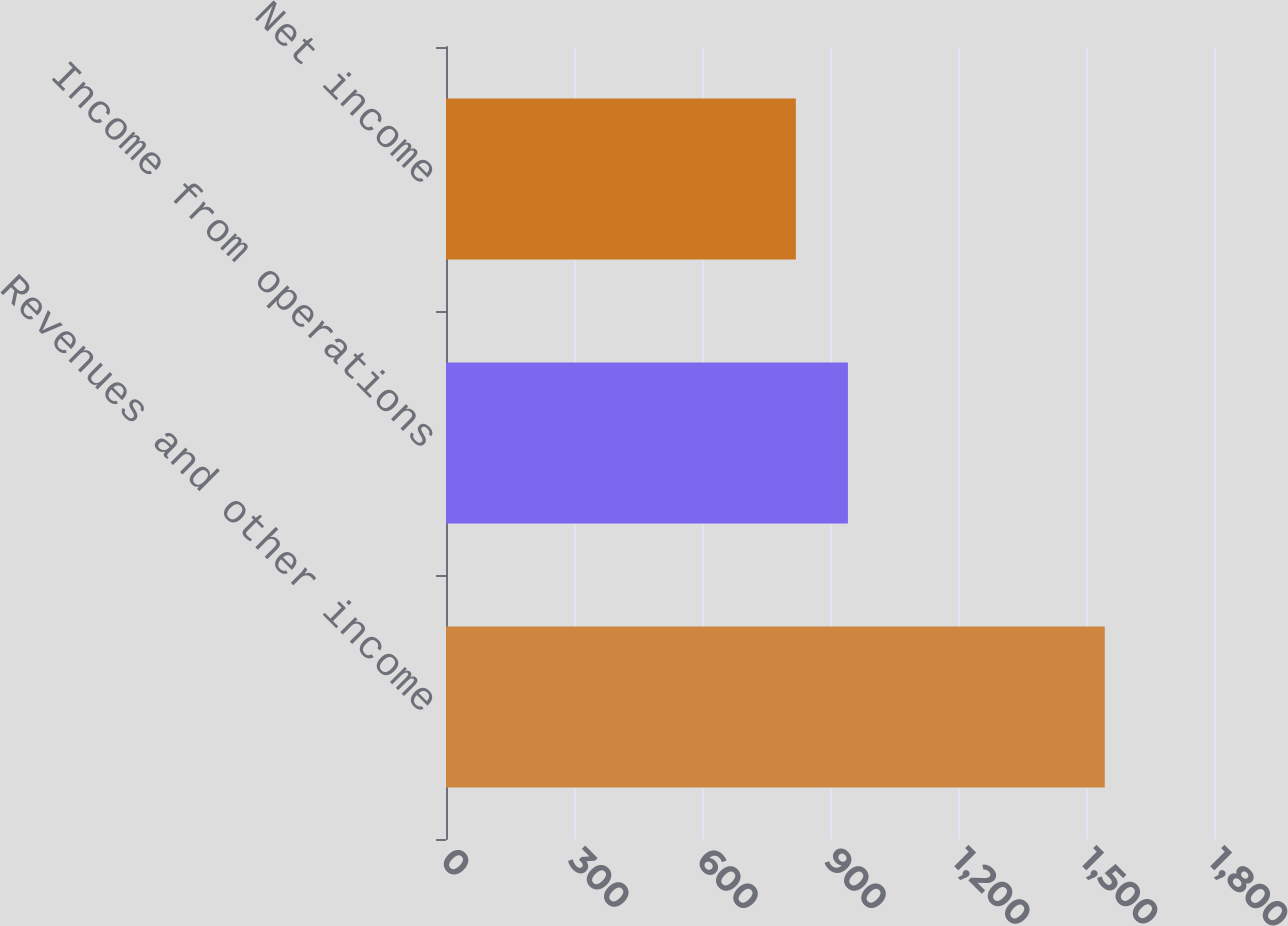Convert chart to OTSL. <chart><loc_0><loc_0><loc_500><loc_500><bar_chart><fcel>Revenues and other income<fcel>Income from operations<fcel>Net income<nl><fcel>1544<fcel>942<fcel>820<nl></chart> 